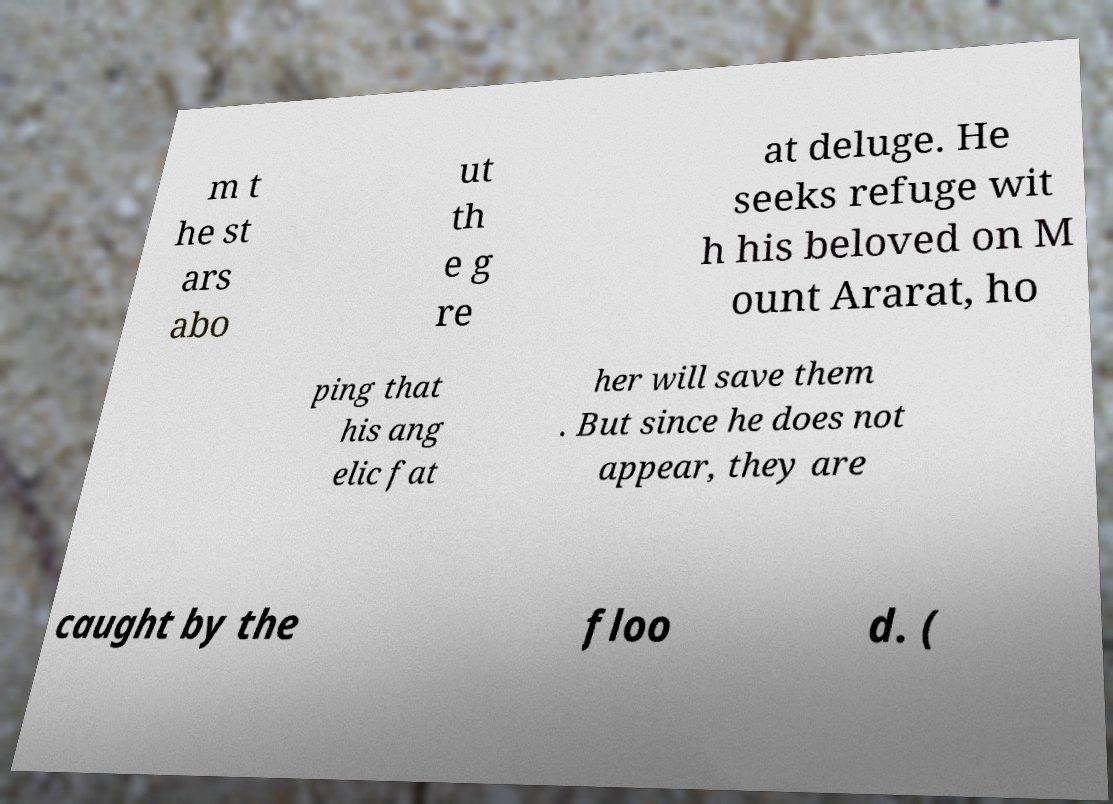Could you assist in decoding the text presented in this image and type it out clearly? m t he st ars abo ut th e g re at deluge. He seeks refuge wit h his beloved on M ount Ararat, ho ping that his ang elic fat her will save them . But since he does not appear, they are caught by the floo d. ( 